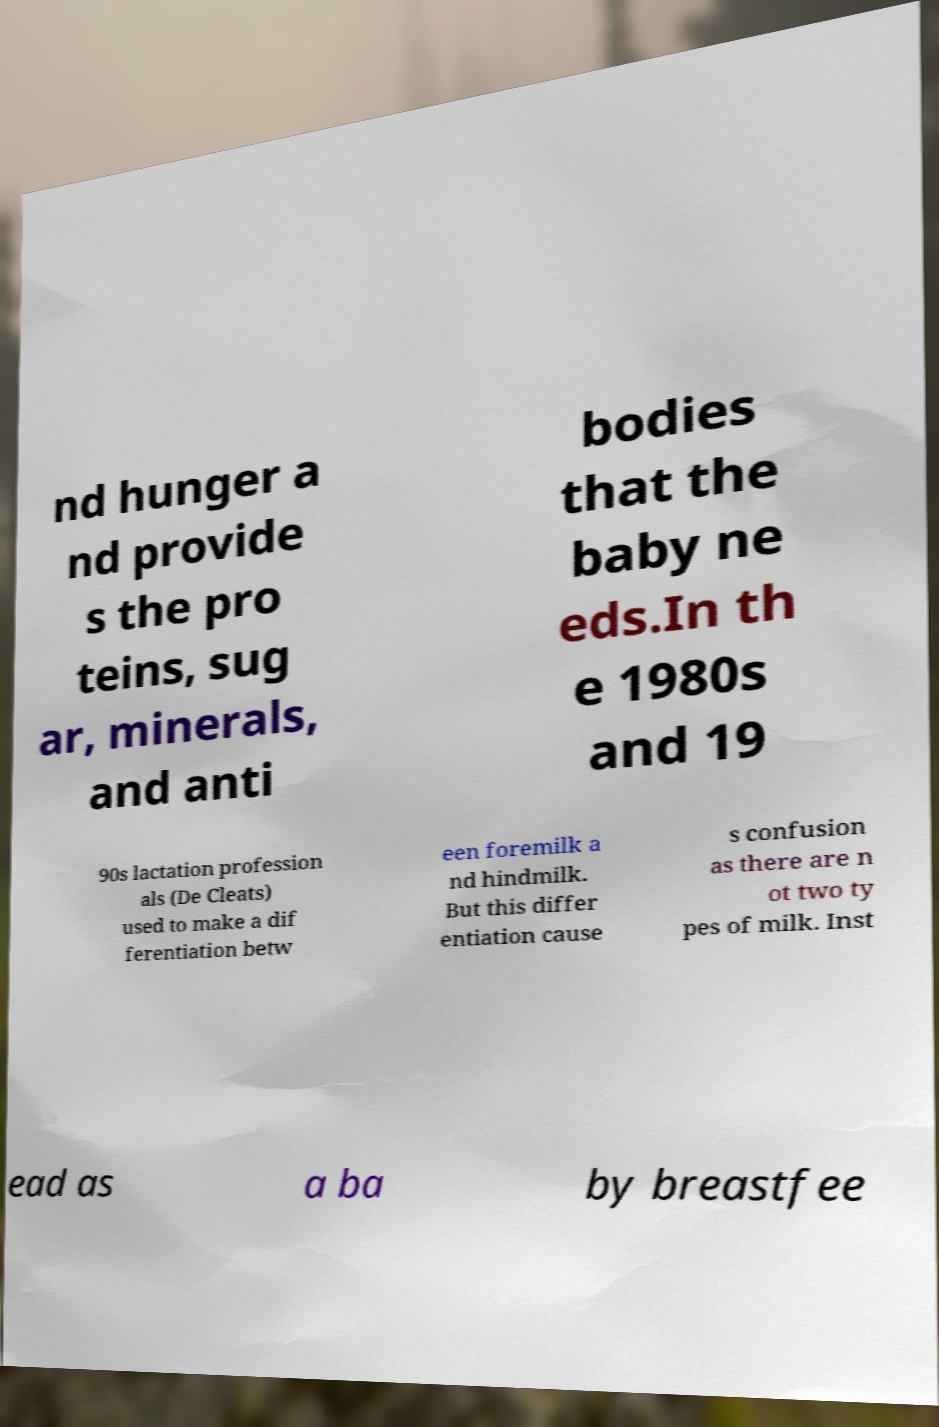For documentation purposes, I need the text within this image transcribed. Could you provide that? nd hunger a nd provide s the pro teins, sug ar, minerals, and anti bodies that the baby ne eds.In th e 1980s and 19 90s lactation profession als (De Cleats) used to make a dif ferentiation betw een foremilk a nd hindmilk. But this differ entiation cause s confusion as there are n ot two ty pes of milk. Inst ead as a ba by breastfee 